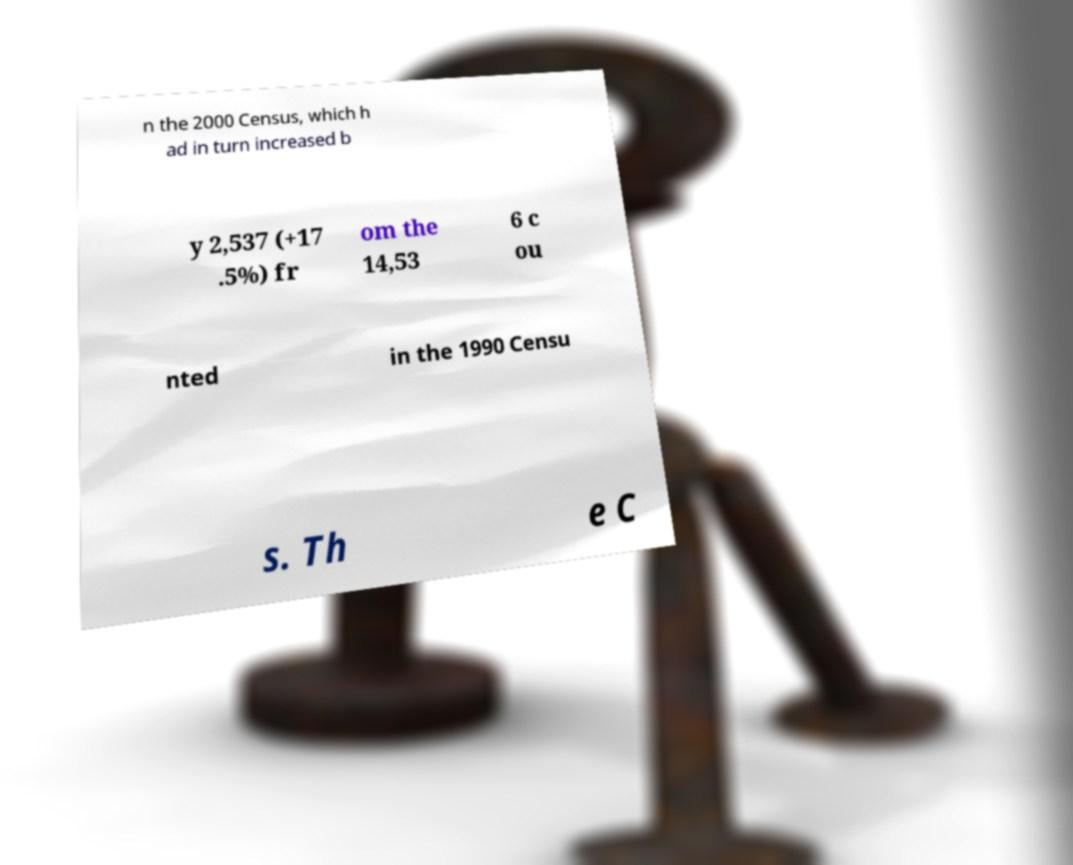What messages or text are displayed in this image? I need them in a readable, typed format. n the 2000 Census, which h ad in turn increased b y 2,537 (+17 .5%) fr om the 14,53 6 c ou nted in the 1990 Censu s. Th e C 